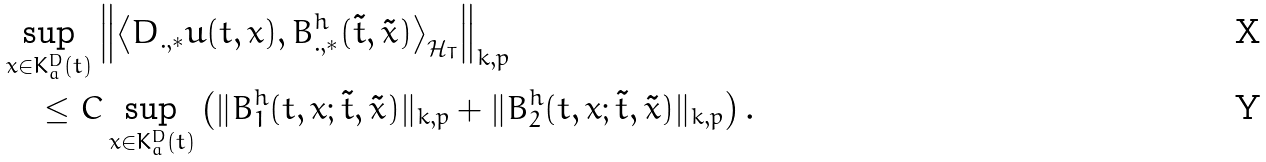<formula> <loc_0><loc_0><loc_500><loc_500>& \sup _ { x \in K _ { a } ^ { D } ( t ) } \left \| \left \langle D _ { . , \ast } u ( t , x ) , B ^ { h } _ { . , \ast } ( \tilde { t } , \tilde { x } ) \right \rangle _ { \mathcal { H } _ { T } } \right \| _ { k , p } \\ & \quad \leq C \sup _ { x \in K _ { a } ^ { D } ( t ) } \left ( \| B _ { 1 } ^ { h } ( t , x ; \tilde { t } , \tilde { x } ) \| _ { k , p } + \| B _ { 2 } ^ { h } ( t , x ; \tilde { t } , \tilde { x } ) \| _ { k , p } \right ) .</formula> 